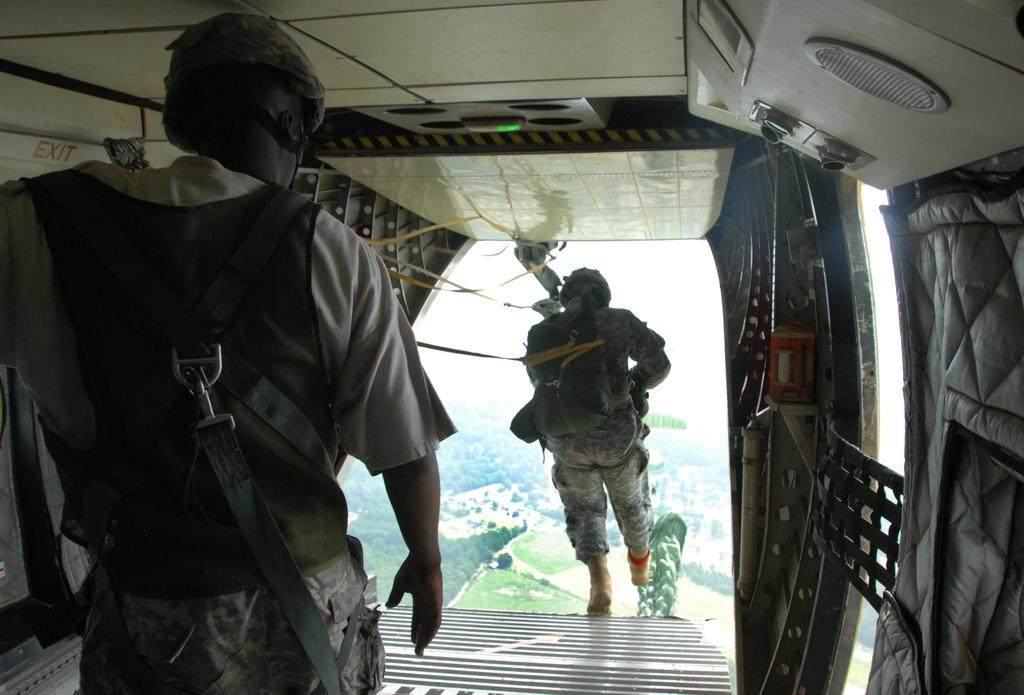How many people are in the image? There are two persons in the image. Where is the image taken? The image is an inside view of an aircraft. What can be seen in the background of the image? Trees and grass are visible in the background of the image. What are the two persons wearing? The two persons are wearing helmets. Can you see a hen walking along the seashore in the image? There is no hen or seashore present in the image; it is an inside view of an aircraft. 